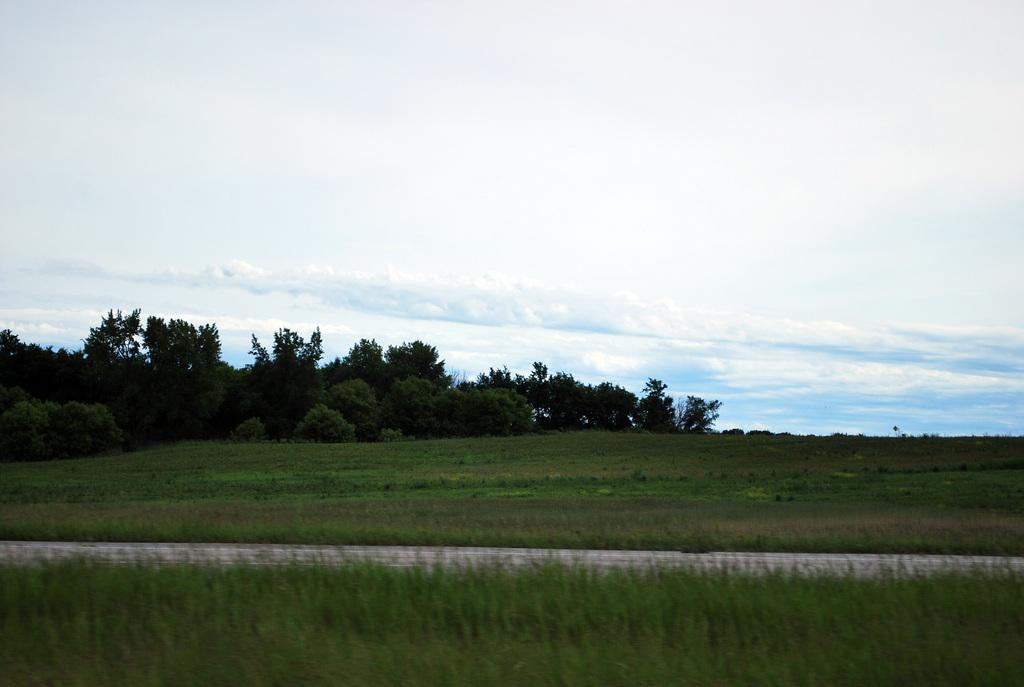What type of vegetation is visible in the image? There is grass in the image. What can be seen in the background of the image? There are trees and the sky visible in the background of the image. What is the condition of the sky in the image? Clouds are present in the sky. What type of coil can be seen in the middle of the image? There is no coil present in the image. What animal can be seen interacting with the grass in the image? There is no animal present in the image; it only features grass, trees, and the sky. 